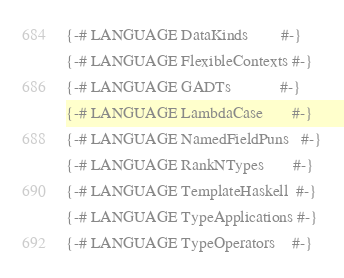<code> <loc_0><loc_0><loc_500><loc_500><_Haskell_>{-# LANGUAGE DataKinds        #-}
{-# LANGUAGE FlexibleContexts #-}
{-# LANGUAGE GADTs            #-}
{-# LANGUAGE LambdaCase       #-}
{-# LANGUAGE NamedFieldPuns   #-}
{-# LANGUAGE RankNTypes       #-}
{-# LANGUAGE TemplateHaskell  #-}
{-# LANGUAGE TypeApplications #-}
{-# LANGUAGE TypeOperators    #-}</code> 